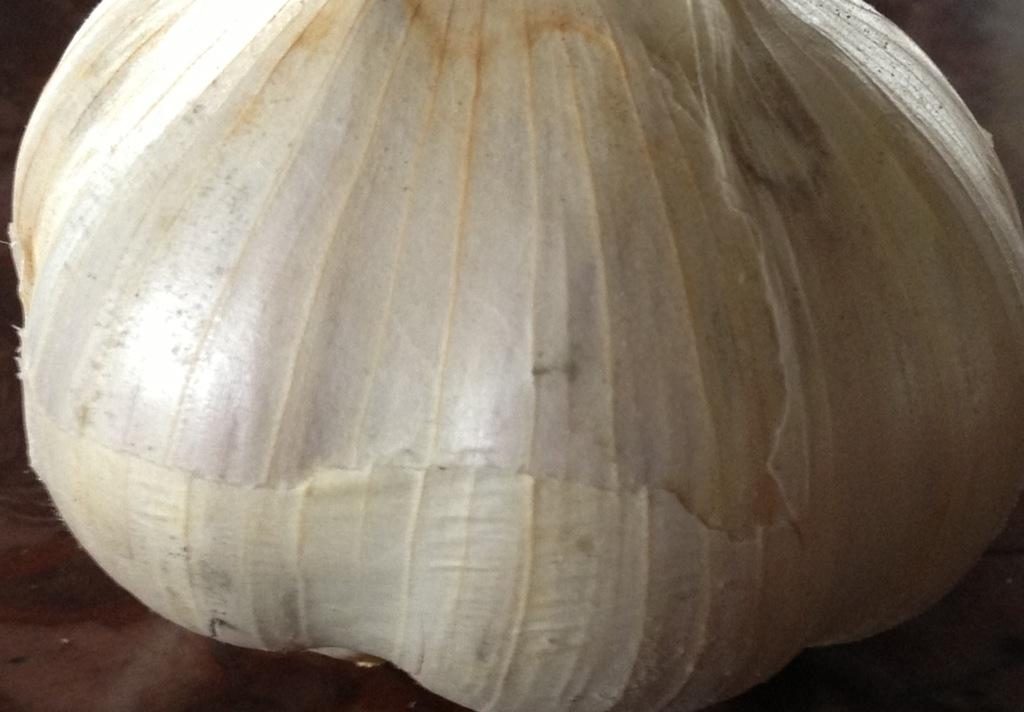What is the main subject of the image? The main subject of the image is garlic. Can you describe the color of the garlic? The garlic is white in color. What type of surface is the garlic placed on? The garlic is on a wooden surface. How does the kite in the image represent hope? There is no kite present in the image, so it cannot represent hope in this context. 